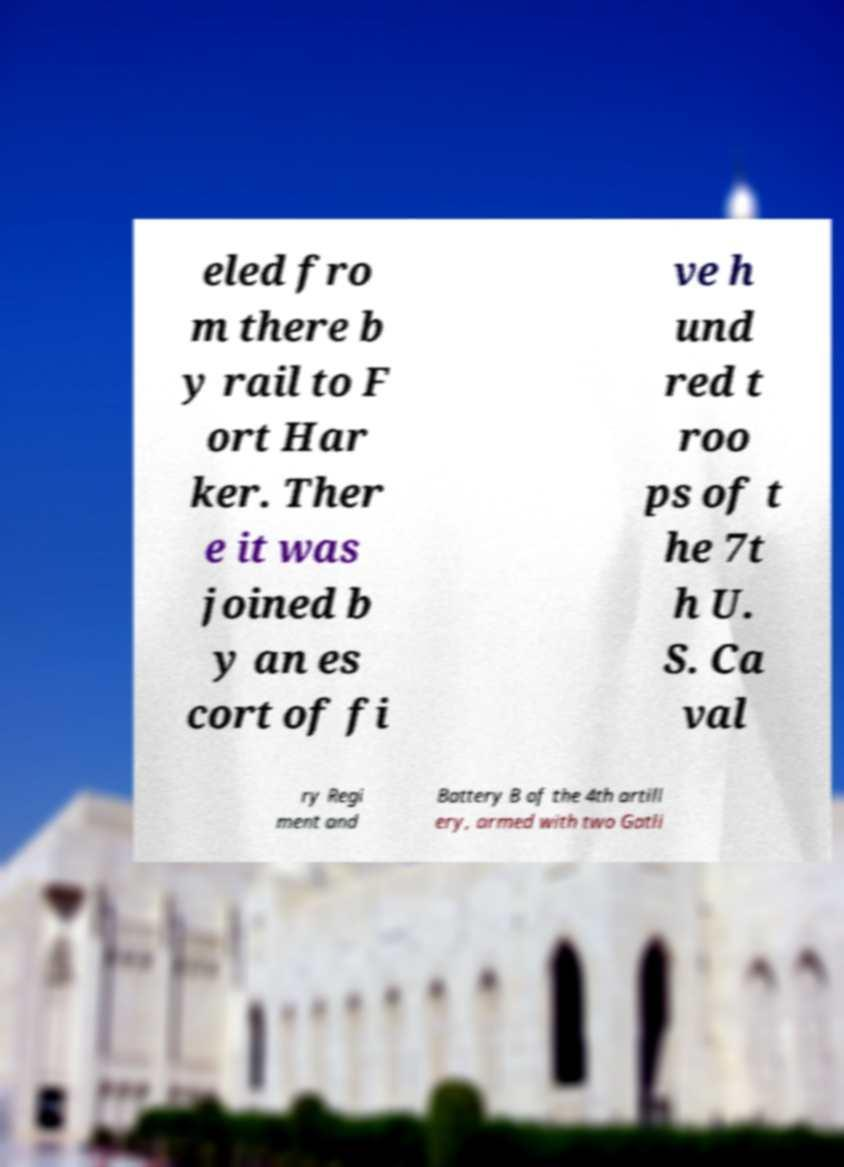Can you accurately transcribe the text from the provided image for me? eled fro m there b y rail to F ort Har ker. Ther e it was joined b y an es cort of fi ve h und red t roo ps of t he 7t h U. S. Ca val ry Regi ment and Battery B of the 4th artill ery, armed with two Gatli 